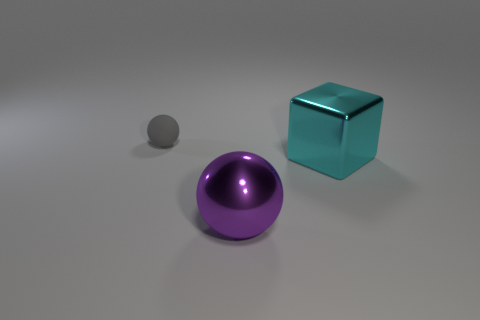The big thing to the right of the purple metallic thing is what color?
Make the answer very short. Cyan. Is the number of balls that are on the right side of the tiny gray ball greater than the number of big brown shiny balls?
Give a very brief answer. Yes. Does the big purple object have the same material as the block?
Keep it short and to the point. Yes. What number of other things are the same shape as the large cyan object?
Your answer should be very brief. 0. Are there any other things that have the same material as the small gray sphere?
Your answer should be very brief. No. There is a metal thing that is behind the ball that is right of the object on the left side of the purple metallic ball; what is its color?
Offer a very short reply. Cyan. There is a thing that is to the left of the purple shiny ball; is it the same shape as the big purple shiny object?
Your answer should be compact. Yes. What number of tiny gray matte things are there?
Offer a very short reply. 1. How many green matte objects have the same size as the shiny sphere?
Provide a short and direct response. 0. What material is the big purple thing?
Ensure brevity in your answer.  Metal. 